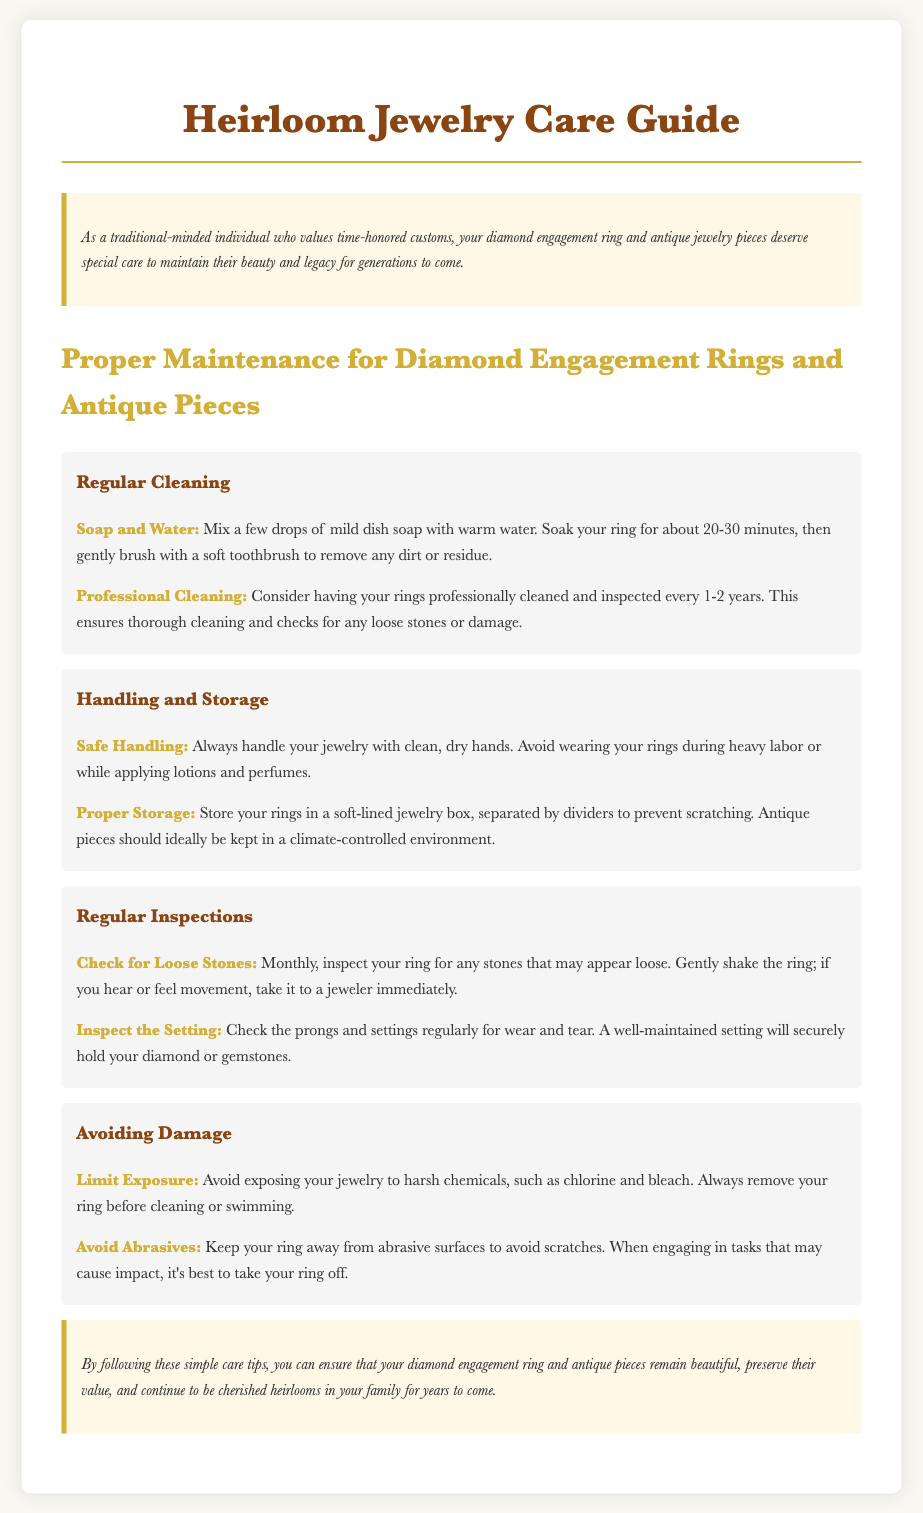what should you mix with warm water for cleaning? The document mentions mixing a few drops of mild dish soap with warm water for cleaning jewelry.
Answer: mild dish soap how often should you have your rings professionally cleaned? The guide suggests having rings professionally cleaned and inspected every 1-2 years.
Answer: 1-2 years what is the suitable environment for storing antique pieces? The document advises storing antique pieces in a climate-controlled environment.
Answer: climate-controlled environment how frequently should you inspect your ring for loose stones? The text indicates that you should check your ring for loose stones monthly.
Answer: monthly what should you avoid exposing your jewelry to during cleaning? The document strongly recommends avoiding exposure to harsh chemicals during cleaning.
Answer: harsh chemicals what is recommended for safe handling of your jewelry? The document suggests always handling jewelry with clean, dry hands.
Answer: clean, dry hands what type of surface should you keep your ring away from? It is recommended to keep your ring away from abrasive surfaces according to the care guide.
Answer: abrasive surfaces what should you do if you hear or feel movement in your ring? The document advises taking the ring to a jeweler immediately if you hear or feel movement.
Answer: take it to a jeweler immediately 